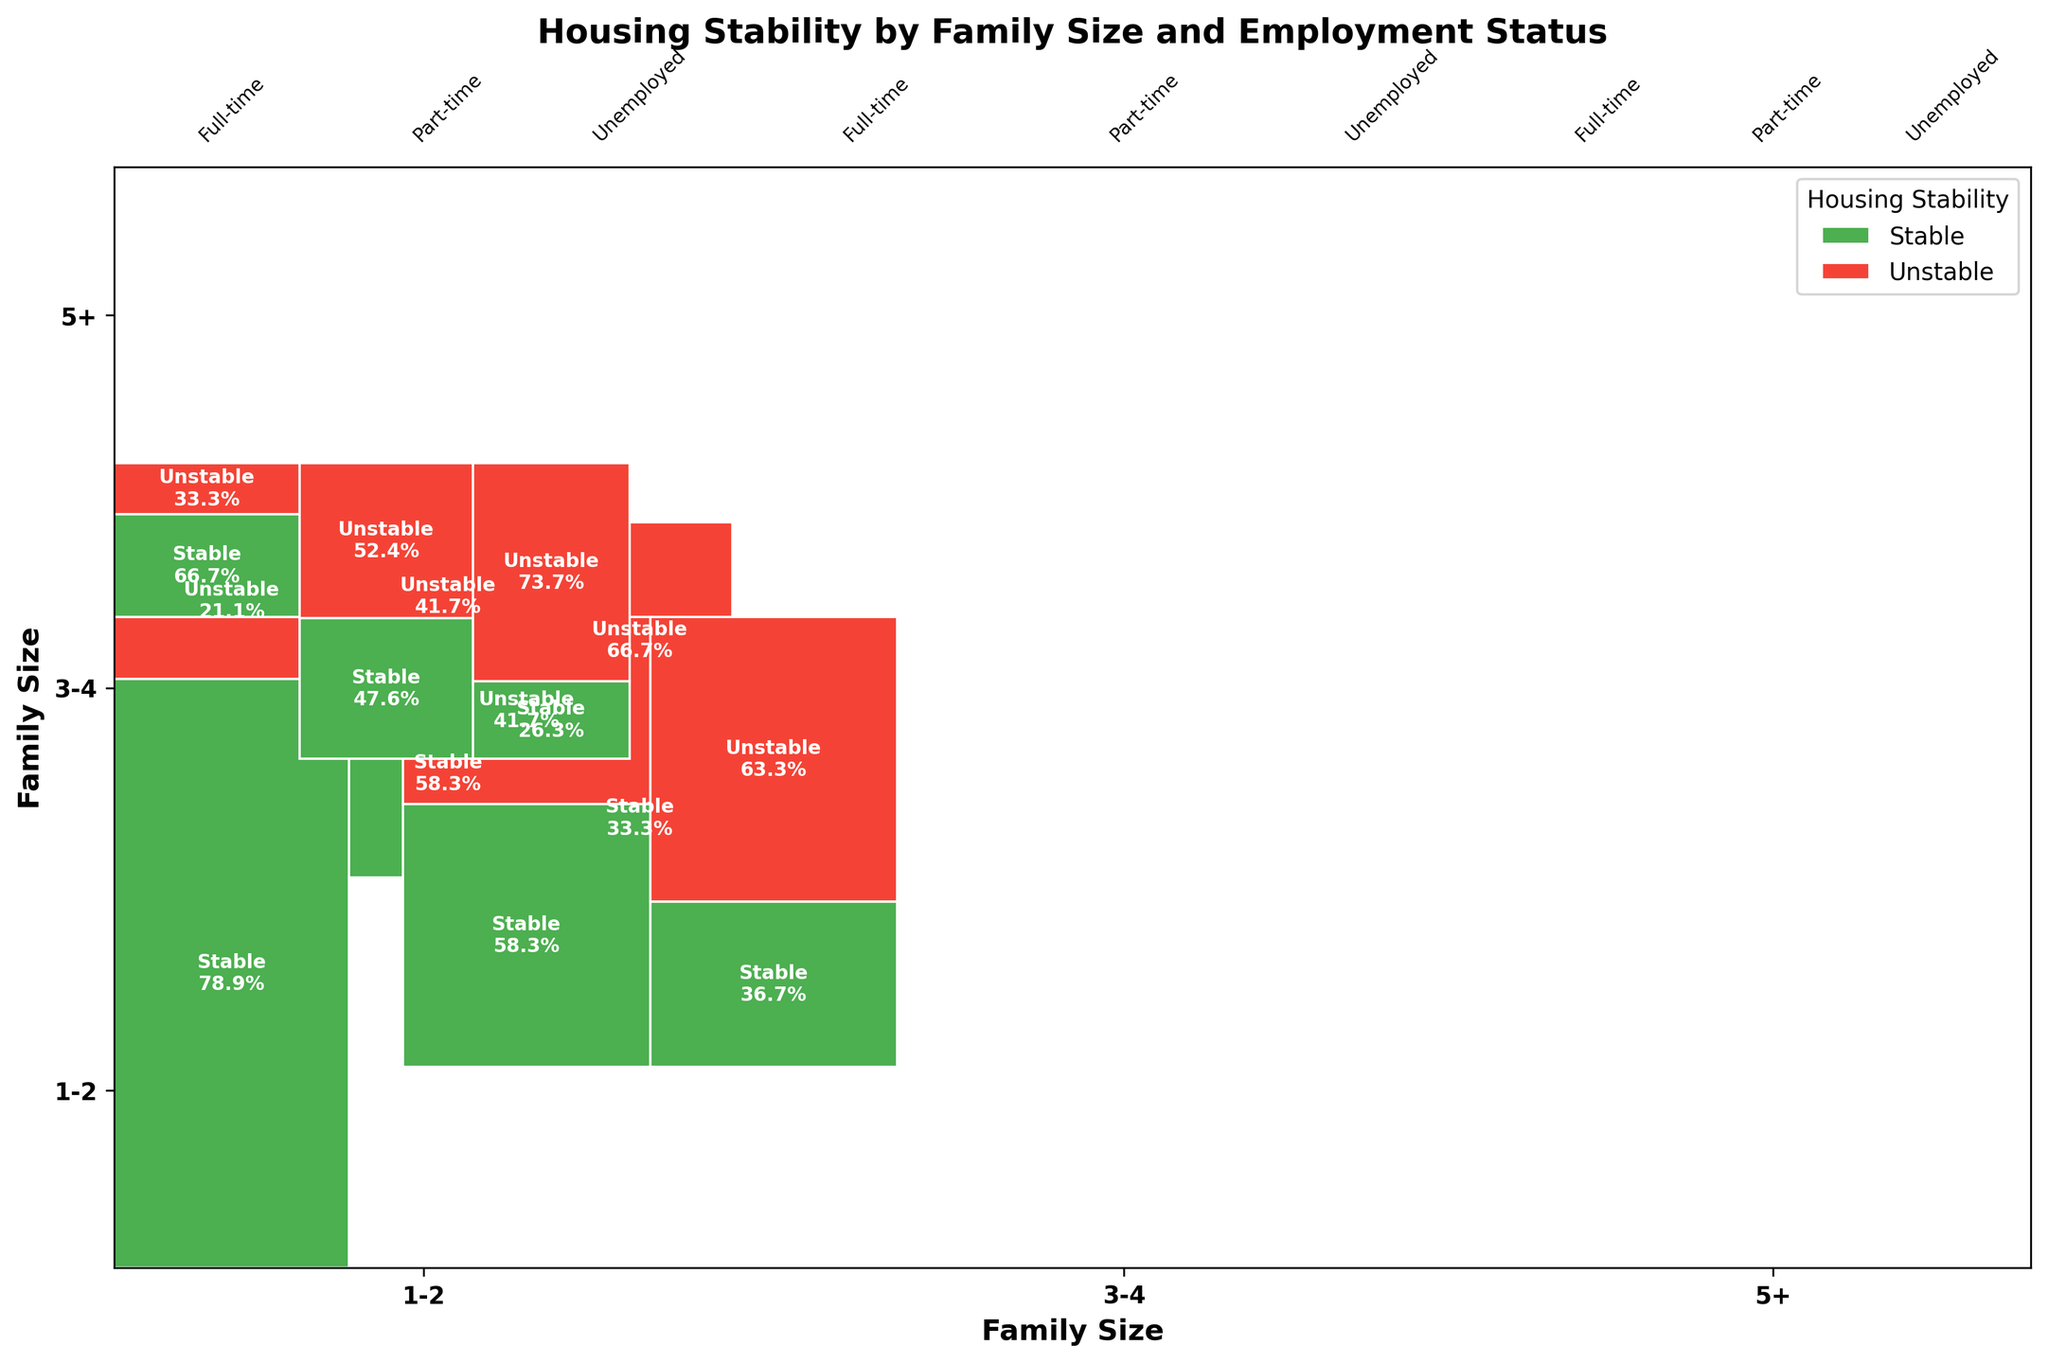What are the two types of housing stability represented in the mosaic plot? The colors in the plot represent two types of housing stability. The green color represents 'Stable' housing, and the red color represents 'Unstable' housing.
Answer: Stable and Unstable Which family size has the highest proportion of stable housing with full-time employment? Looking at the rectangles representing full-time employment within each family size, the '3-4' family size has the largest green area, indicating the highest proportion of stable housing.
Answer: Family size 3-4 What is the total proportion of stable housing for family sizes 1-2 and 3-4 with part-time employment? We need to sum the proportions of the stable housing segment for both family sizes with part-time employment. First, identify the green segments for part-time in both family sizes. Then, sum these values to get the total proportion.
Answer: 53% Which family size has the smallest proportion of stable housing among unemployed participants? Examine the green segments within the categories of unemployed participants. The family size '5+' has the smallest green segment, indicating the smallest proportion of stable housing.
Answer: Family size 5+ How does the proportion of unstable housing compare between part-time and unemployed participants in family size 5+? Compare the red rectangles for 'Part-time' and 'Unemployed' participants in the '5+' family size category. The proportion of unstable housing is larger for 'Unemployed' participants.
Answer: Larger for Unemployed What percentage of participants with full-time employment and family size 1-2 experience unstable housing? Identify the red segment in the full-time employment section for family size 1-2. The label on or near this segment will show the percentage.
Answer: 12% Which employment status has the highest stability within the '5+' family size category? Examine the green segments within each employment status for the '5+' family size. The full-time employment status has the largest green segment, indicating the highest stability.
Answer: Full-time Is there a family size where the stable housing proportion decreases as employment status changes from full-time to unemployed? Compare the green segments' sizes across employment statuses (full-time, part-time, unemployed) for each family size. The family size '3-4' shows a decrease in stability from full-time to unemployed.
Answer: Family size 3-4 What is the visual trend in housing stability as family size increases for participants with full-time employment? Observe the green segments for full-time employment across different family sizes. The stable housing proportion is highest in family size '3-4', but it decreases when moving to family size '5+'.
Answer: Decreases 